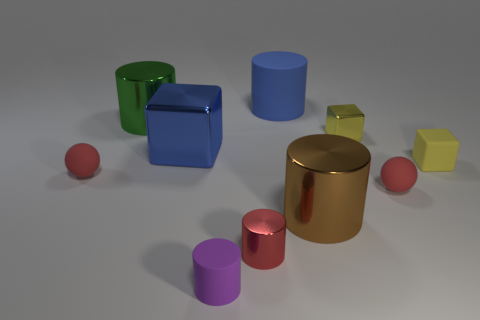How many big metallic cylinders are left of the brown metallic cylinder and right of the big green cylinder? There are no big metallic cylinders positioned to the left of the brown metallic cylinder and to the right of the big green cylinder. 